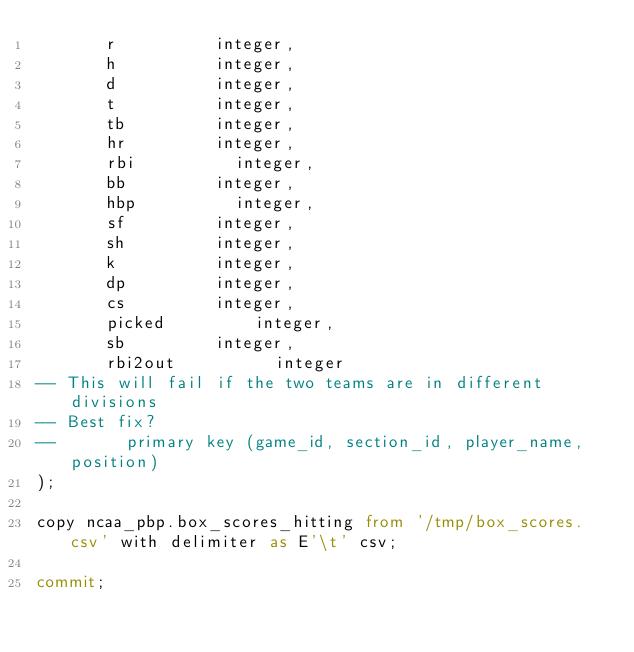<code> <loc_0><loc_0><loc_500><loc_500><_SQL_>       r					integer,
       h					integer,
       d					integer,
       t					integer,
       tb					integer,
       hr					integer,
       rbi					integer,
       bb					integer,
       hbp					integer,
       sf					integer,
       sh					integer,
       k					integer,
       dp					integer,
       cs					integer,
       picked					integer,
       sb					integer,
       rbi2out					integer
-- This will fail if the two teams are in different divisions
-- Best fix?
--       primary key (game_id, section_id, player_name, position)
);

copy ncaa_pbp.box_scores_hitting from '/tmp/box_scores.csv' with delimiter as E'\t' csv;

commit;
</code> 